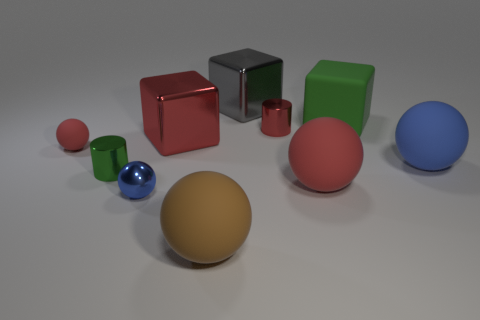How many red spheres must be subtracted to get 1 red spheres? 1 Subtract all blue cubes. Subtract all gray balls. How many cubes are left? 3 Subtract all cubes. How many objects are left? 7 Add 7 large yellow metallic cubes. How many large yellow metallic cubes exist? 7 Subtract 0 yellow cubes. How many objects are left? 10 Subtract all brown matte balls. Subtract all blue matte things. How many objects are left? 8 Add 3 brown rubber spheres. How many brown rubber spheres are left? 4 